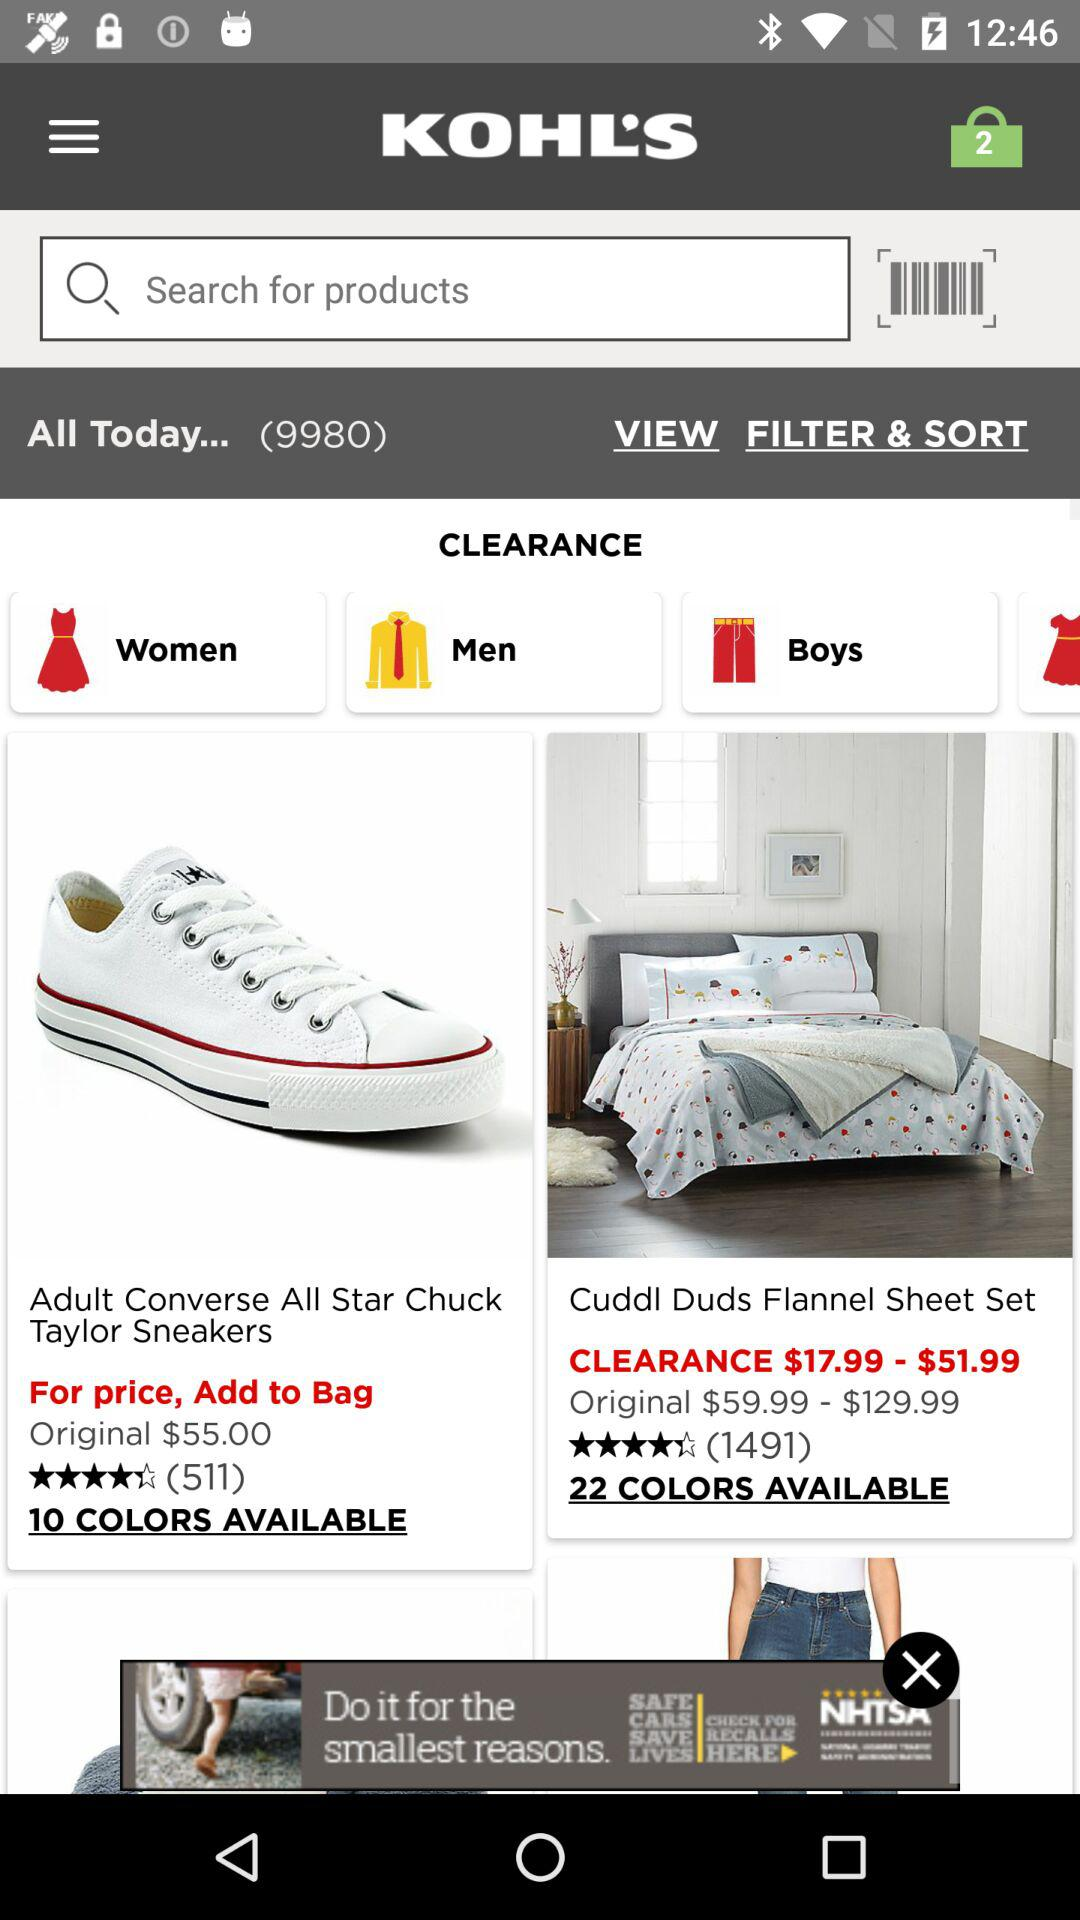What is the price of "Adult Converse All Star Chuck Taylor Sneakers"? The price is $55.00. 